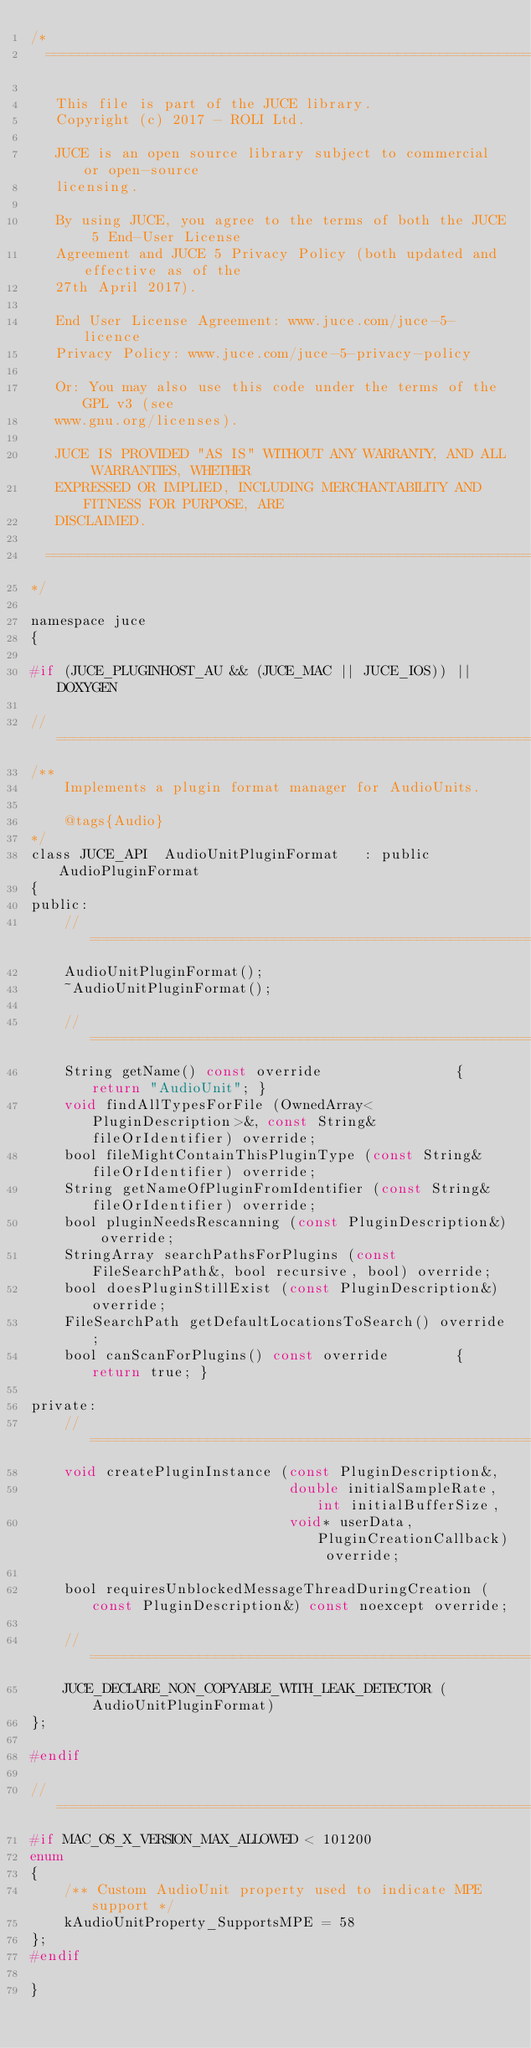<code> <loc_0><loc_0><loc_500><loc_500><_C_>/*
  ==============================================================================

   This file is part of the JUCE library.
   Copyright (c) 2017 - ROLI Ltd.

   JUCE is an open source library subject to commercial or open-source
   licensing.

   By using JUCE, you agree to the terms of both the JUCE 5 End-User License
   Agreement and JUCE 5 Privacy Policy (both updated and effective as of the
   27th April 2017).

   End User License Agreement: www.juce.com/juce-5-licence
   Privacy Policy: www.juce.com/juce-5-privacy-policy

   Or: You may also use this code under the terms of the GPL v3 (see
   www.gnu.org/licenses).

   JUCE IS PROVIDED "AS IS" WITHOUT ANY WARRANTY, AND ALL WARRANTIES, WHETHER
   EXPRESSED OR IMPLIED, INCLUDING MERCHANTABILITY AND FITNESS FOR PURPOSE, ARE
   DISCLAIMED.

  ==============================================================================
*/

namespace juce
{

#if (JUCE_PLUGINHOST_AU && (JUCE_MAC || JUCE_IOS)) || DOXYGEN

//==============================================================================
/**
    Implements a plugin format manager for AudioUnits.

    @tags{Audio}
*/
class JUCE_API  AudioUnitPluginFormat   : public AudioPluginFormat
{
public:
    //==============================================================================
    AudioUnitPluginFormat();
    ~AudioUnitPluginFormat();

    //==============================================================================
    String getName() const override                { return "AudioUnit"; }
    void findAllTypesForFile (OwnedArray<PluginDescription>&, const String& fileOrIdentifier) override;
    bool fileMightContainThisPluginType (const String& fileOrIdentifier) override;
    String getNameOfPluginFromIdentifier (const String& fileOrIdentifier) override;
    bool pluginNeedsRescanning (const PluginDescription&) override;
    StringArray searchPathsForPlugins (const FileSearchPath&, bool recursive, bool) override;
    bool doesPluginStillExist (const PluginDescription&) override;
    FileSearchPath getDefaultLocationsToSearch() override;
    bool canScanForPlugins() const override        { return true; }

private:
    //==============================================================================
    void createPluginInstance (const PluginDescription&,
                               double initialSampleRate, int initialBufferSize,
                               void* userData, PluginCreationCallback) override;

    bool requiresUnblockedMessageThreadDuringCreation (const PluginDescription&) const noexcept override;

    //==============================================================================
    JUCE_DECLARE_NON_COPYABLE_WITH_LEAK_DETECTOR (AudioUnitPluginFormat)
};

#endif

//==============================================================================
#if MAC_OS_X_VERSION_MAX_ALLOWED < 101200
enum
{
    /** Custom AudioUnit property used to indicate MPE support */
    kAudioUnitProperty_SupportsMPE = 58
};
#endif

}
</code> 